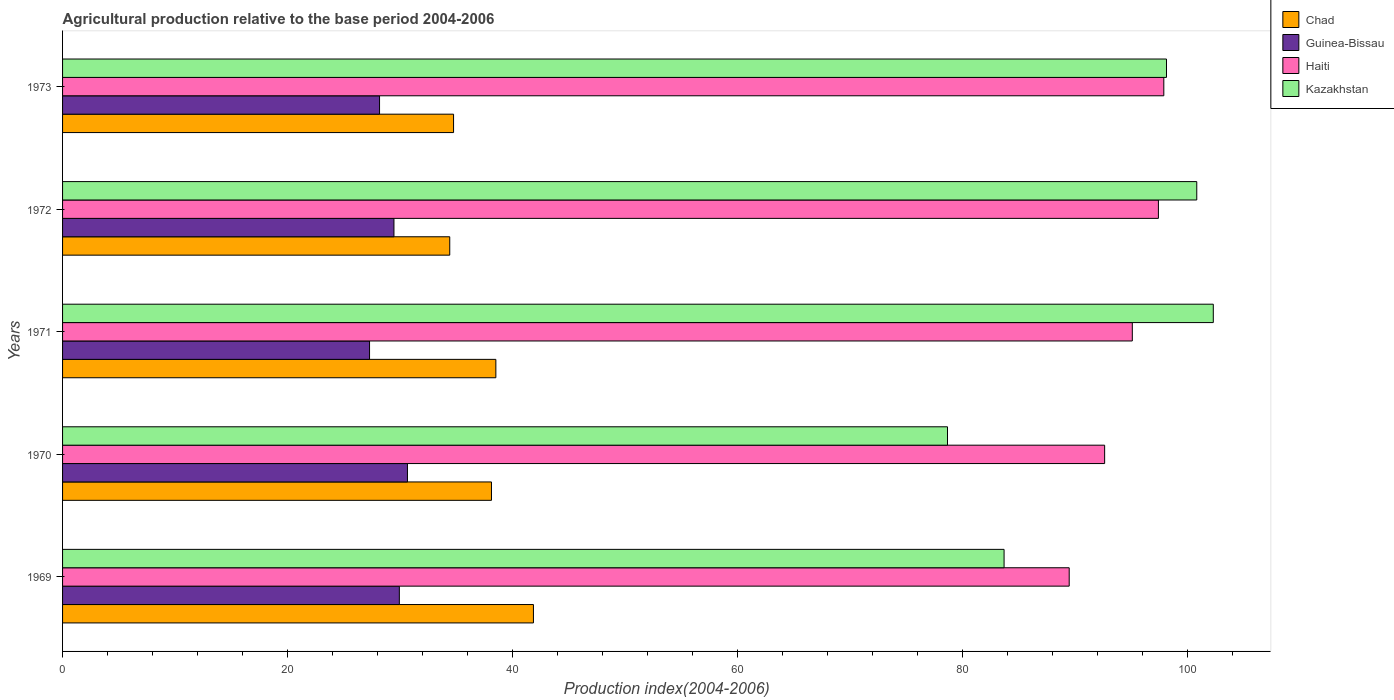How many different coloured bars are there?
Your answer should be compact. 4. How many groups of bars are there?
Ensure brevity in your answer.  5. Are the number of bars per tick equal to the number of legend labels?
Make the answer very short. Yes. Are the number of bars on each tick of the Y-axis equal?
Offer a terse response. Yes. How many bars are there on the 4th tick from the top?
Offer a very short reply. 4. What is the label of the 2nd group of bars from the top?
Offer a terse response. 1972. What is the agricultural production index in Chad in 1969?
Provide a short and direct response. 41.86. Across all years, what is the maximum agricultural production index in Haiti?
Your answer should be compact. 97.9. Across all years, what is the minimum agricultural production index in Guinea-Bissau?
Provide a succinct answer. 27.29. In which year was the agricultural production index in Chad maximum?
Give a very brief answer. 1969. In which year was the agricultural production index in Guinea-Bissau minimum?
Ensure brevity in your answer.  1971. What is the total agricultural production index in Chad in the graph?
Give a very brief answer. 187.69. What is the difference between the agricultural production index in Guinea-Bissau in 1969 and that in 1972?
Your answer should be compact. 0.48. What is the difference between the agricultural production index in Chad in 1973 and the agricultural production index in Guinea-Bissau in 1972?
Offer a very short reply. 5.3. What is the average agricultural production index in Kazakhstan per year?
Your answer should be compact. 92.73. In the year 1973, what is the difference between the agricultural production index in Kazakhstan and agricultural production index in Chad?
Your answer should be very brief. 63.38. In how many years, is the agricultural production index in Haiti greater than 96 ?
Keep it short and to the point. 2. What is the ratio of the agricultural production index in Chad in 1969 to that in 1973?
Ensure brevity in your answer.  1.2. Is the agricultural production index in Guinea-Bissau in 1969 less than that in 1970?
Make the answer very short. Yes. What is the difference between the highest and the second highest agricultural production index in Chad?
Your answer should be compact. 3.34. What is the difference between the highest and the lowest agricultural production index in Guinea-Bissau?
Keep it short and to the point. 3.37. Is it the case that in every year, the sum of the agricultural production index in Chad and agricultural production index in Kazakhstan is greater than the sum of agricultural production index in Haiti and agricultural production index in Guinea-Bissau?
Provide a succinct answer. Yes. What does the 2nd bar from the top in 1971 represents?
Give a very brief answer. Haiti. What does the 3rd bar from the bottom in 1969 represents?
Offer a very short reply. Haiti. Is it the case that in every year, the sum of the agricultural production index in Haiti and agricultural production index in Guinea-Bissau is greater than the agricultural production index in Chad?
Your response must be concise. Yes. Are all the bars in the graph horizontal?
Provide a succinct answer. Yes. How many legend labels are there?
Give a very brief answer. 4. What is the title of the graph?
Offer a very short reply. Agricultural production relative to the base period 2004-2006. Does "Turkey" appear as one of the legend labels in the graph?
Make the answer very short. No. What is the label or title of the X-axis?
Your response must be concise. Production index(2004-2006). What is the Production index(2004-2006) of Chad in 1969?
Your answer should be compact. 41.86. What is the Production index(2004-2006) in Guinea-Bissau in 1969?
Keep it short and to the point. 29.94. What is the Production index(2004-2006) of Haiti in 1969?
Make the answer very short. 89.49. What is the Production index(2004-2006) of Kazakhstan in 1969?
Your response must be concise. 83.7. What is the Production index(2004-2006) in Chad in 1970?
Your response must be concise. 38.13. What is the Production index(2004-2006) of Guinea-Bissau in 1970?
Give a very brief answer. 30.66. What is the Production index(2004-2006) of Haiti in 1970?
Your response must be concise. 92.64. What is the Production index(2004-2006) in Kazakhstan in 1970?
Provide a succinct answer. 78.67. What is the Production index(2004-2006) in Chad in 1971?
Your answer should be compact. 38.52. What is the Production index(2004-2006) in Guinea-Bissau in 1971?
Your answer should be very brief. 27.29. What is the Production index(2004-2006) of Haiti in 1971?
Provide a succinct answer. 95.1. What is the Production index(2004-2006) of Kazakhstan in 1971?
Your response must be concise. 102.3. What is the Production index(2004-2006) of Chad in 1972?
Provide a succinct answer. 34.42. What is the Production index(2004-2006) of Guinea-Bissau in 1972?
Make the answer very short. 29.46. What is the Production index(2004-2006) in Haiti in 1972?
Your answer should be very brief. 97.42. What is the Production index(2004-2006) in Kazakhstan in 1972?
Provide a succinct answer. 100.83. What is the Production index(2004-2006) in Chad in 1973?
Keep it short and to the point. 34.76. What is the Production index(2004-2006) of Guinea-Bissau in 1973?
Provide a short and direct response. 28.18. What is the Production index(2004-2006) of Haiti in 1973?
Give a very brief answer. 97.9. What is the Production index(2004-2006) of Kazakhstan in 1973?
Offer a terse response. 98.14. Across all years, what is the maximum Production index(2004-2006) of Chad?
Provide a short and direct response. 41.86. Across all years, what is the maximum Production index(2004-2006) of Guinea-Bissau?
Give a very brief answer. 30.66. Across all years, what is the maximum Production index(2004-2006) of Haiti?
Make the answer very short. 97.9. Across all years, what is the maximum Production index(2004-2006) in Kazakhstan?
Your answer should be compact. 102.3. Across all years, what is the minimum Production index(2004-2006) in Chad?
Your answer should be very brief. 34.42. Across all years, what is the minimum Production index(2004-2006) of Guinea-Bissau?
Ensure brevity in your answer.  27.29. Across all years, what is the minimum Production index(2004-2006) of Haiti?
Ensure brevity in your answer.  89.49. Across all years, what is the minimum Production index(2004-2006) of Kazakhstan?
Give a very brief answer. 78.67. What is the total Production index(2004-2006) of Chad in the graph?
Give a very brief answer. 187.69. What is the total Production index(2004-2006) of Guinea-Bissau in the graph?
Ensure brevity in your answer.  145.53. What is the total Production index(2004-2006) of Haiti in the graph?
Make the answer very short. 472.55. What is the total Production index(2004-2006) of Kazakhstan in the graph?
Ensure brevity in your answer.  463.64. What is the difference between the Production index(2004-2006) of Chad in 1969 and that in 1970?
Your response must be concise. 3.73. What is the difference between the Production index(2004-2006) of Guinea-Bissau in 1969 and that in 1970?
Keep it short and to the point. -0.72. What is the difference between the Production index(2004-2006) of Haiti in 1969 and that in 1970?
Your response must be concise. -3.15. What is the difference between the Production index(2004-2006) of Kazakhstan in 1969 and that in 1970?
Keep it short and to the point. 5.03. What is the difference between the Production index(2004-2006) in Chad in 1969 and that in 1971?
Ensure brevity in your answer.  3.34. What is the difference between the Production index(2004-2006) in Guinea-Bissau in 1969 and that in 1971?
Make the answer very short. 2.65. What is the difference between the Production index(2004-2006) in Haiti in 1969 and that in 1971?
Give a very brief answer. -5.61. What is the difference between the Production index(2004-2006) in Kazakhstan in 1969 and that in 1971?
Offer a terse response. -18.6. What is the difference between the Production index(2004-2006) of Chad in 1969 and that in 1972?
Your answer should be compact. 7.44. What is the difference between the Production index(2004-2006) of Guinea-Bissau in 1969 and that in 1972?
Provide a succinct answer. 0.48. What is the difference between the Production index(2004-2006) in Haiti in 1969 and that in 1972?
Offer a terse response. -7.93. What is the difference between the Production index(2004-2006) in Kazakhstan in 1969 and that in 1972?
Make the answer very short. -17.13. What is the difference between the Production index(2004-2006) of Guinea-Bissau in 1969 and that in 1973?
Keep it short and to the point. 1.76. What is the difference between the Production index(2004-2006) of Haiti in 1969 and that in 1973?
Provide a succinct answer. -8.41. What is the difference between the Production index(2004-2006) in Kazakhstan in 1969 and that in 1973?
Give a very brief answer. -14.44. What is the difference between the Production index(2004-2006) of Chad in 1970 and that in 1971?
Give a very brief answer. -0.39. What is the difference between the Production index(2004-2006) in Guinea-Bissau in 1970 and that in 1971?
Keep it short and to the point. 3.37. What is the difference between the Production index(2004-2006) in Haiti in 1970 and that in 1971?
Provide a short and direct response. -2.46. What is the difference between the Production index(2004-2006) in Kazakhstan in 1970 and that in 1971?
Provide a succinct answer. -23.63. What is the difference between the Production index(2004-2006) of Chad in 1970 and that in 1972?
Provide a short and direct response. 3.71. What is the difference between the Production index(2004-2006) in Haiti in 1970 and that in 1972?
Provide a short and direct response. -4.78. What is the difference between the Production index(2004-2006) of Kazakhstan in 1970 and that in 1972?
Ensure brevity in your answer.  -22.16. What is the difference between the Production index(2004-2006) in Chad in 1970 and that in 1973?
Keep it short and to the point. 3.37. What is the difference between the Production index(2004-2006) of Guinea-Bissau in 1970 and that in 1973?
Provide a succinct answer. 2.48. What is the difference between the Production index(2004-2006) in Haiti in 1970 and that in 1973?
Offer a terse response. -5.26. What is the difference between the Production index(2004-2006) of Kazakhstan in 1970 and that in 1973?
Offer a terse response. -19.47. What is the difference between the Production index(2004-2006) of Chad in 1971 and that in 1972?
Your answer should be very brief. 4.1. What is the difference between the Production index(2004-2006) of Guinea-Bissau in 1971 and that in 1972?
Your response must be concise. -2.17. What is the difference between the Production index(2004-2006) of Haiti in 1971 and that in 1972?
Your answer should be compact. -2.32. What is the difference between the Production index(2004-2006) in Kazakhstan in 1971 and that in 1972?
Give a very brief answer. 1.47. What is the difference between the Production index(2004-2006) in Chad in 1971 and that in 1973?
Provide a succinct answer. 3.76. What is the difference between the Production index(2004-2006) in Guinea-Bissau in 1971 and that in 1973?
Keep it short and to the point. -0.89. What is the difference between the Production index(2004-2006) of Kazakhstan in 1971 and that in 1973?
Provide a short and direct response. 4.16. What is the difference between the Production index(2004-2006) in Chad in 1972 and that in 1973?
Provide a short and direct response. -0.34. What is the difference between the Production index(2004-2006) of Guinea-Bissau in 1972 and that in 1973?
Offer a terse response. 1.28. What is the difference between the Production index(2004-2006) of Haiti in 1972 and that in 1973?
Ensure brevity in your answer.  -0.48. What is the difference between the Production index(2004-2006) of Kazakhstan in 1972 and that in 1973?
Provide a short and direct response. 2.69. What is the difference between the Production index(2004-2006) in Chad in 1969 and the Production index(2004-2006) in Guinea-Bissau in 1970?
Give a very brief answer. 11.2. What is the difference between the Production index(2004-2006) in Chad in 1969 and the Production index(2004-2006) in Haiti in 1970?
Keep it short and to the point. -50.78. What is the difference between the Production index(2004-2006) of Chad in 1969 and the Production index(2004-2006) of Kazakhstan in 1970?
Make the answer very short. -36.81. What is the difference between the Production index(2004-2006) in Guinea-Bissau in 1969 and the Production index(2004-2006) in Haiti in 1970?
Provide a short and direct response. -62.7. What is the difference between the Production index(2004-2006) in Guinea-Bissau in 1969 and the Production index(2004-2006) in Kazakhstan in 1970?
Offer a terse response. -48.73. What is the difference between the Production index(2004-2006) of Haiti in 1969 and the Production index(2004-2006) of Kazakhstan in 1970?
Offer a terse response. 10.82. What is the difference between the Production index(2004-2006) of Chad in 1969 and the Production index(2004-2006) of Guinea-Bissau in 1971?
Keep it short and to the point. 14.57. What is the difference between the Production index(2004-2006) of Chad in 1969 and the Production index(2004-2006) of Haiti in 1971?
Provide a short and direct response. -53.24. What is the difference between the Production index(2004-2006) in Chad in 1969 and the Production index(2004-2006) in Kazakhstan in 1971?
Offer a terse response. -60.44. What is the difference between the Production index(2004-2006) of Guinea-Bissau in 1969 and the Production index(2004-2006) of Haiti in 1971?
Keep it short and to the point. -65.16. What is the difference between the Production index(2004-2006) in Guinea-Bissau in 1969 and the Production index(2004-2006) in Kazakhstan in 1971?
Offer a very short reply. -72.36. What is the difference between the Production index(2004-2006) in Haiti in 1969 and the Production index(2004-2006) in Kazakhstan in 1971?
Provide a succinct answer. -12.81. What is the difference between the Production index(2004-2006) in Chad in 1969 and the Production index(2004-2006) in Guinea-Bissau in 1972?
Your answer should be compact. 12.4. What is the difference between the Production index(2004-2006) of Chad in 1969 and the Production index(2004-2006) of Haiti in 1972?
Offer a very short reply. -55.56. What is the difference between the Production index(2004-2006) in Chad in 1969 and the Production index(2004-2006) in Kazakhstan in 1972?
Your answer should be very brief. -58.97. What is the difference between the Production index(2004-2006) in Guinea-Bissau in 1969 and the Production index(2004-2006) in Haiti in 1972?
Your answer should be compact. -67.48. What is the difference between the Production index(2004-2006) of Guinea-Bissau in 1969 and the Production index(2004-2006) of Kazakhstan in 1972?
Provide a short and direct response. -70.89. What is the difference between the Production index(2004-2006) in Haiti in 1969 and the Production index(2004-2006) in Kazakhstan in 1972?
Your answer should be compact. -11.34. What is the difference between the Production index(2004-2006) of Chad in 1969 and the Production index(2004-2006) of Guinea-Bissau in 1973?
Offer a terse response. 13.68. What is the difference between the Production index(2004-2006) in Chad in 1969 and the Production index(2004-2006) in Haiti in 1973?
Your response must be concise. -56.04. What is the difference between the Production index(2004-2006) in Chad in 1969 and the Production index(2004-2006) in Kazakhstan in 1973?
Your response must be concise. -56.28. What is the difference between the Production index(2004-2006) of Guinea-Bissau in 1969 and the Production index(2004-2006) of Haiti in 1973?
Make the answer very short. -67.96. What is the difference between the Production index(2004-2006) in Guinea-Bissau in 1969 and the Production index(2004-2006) in Kazakhstan in 1973?
Offer a very short reply. -68.2. What is the difference between the Production index(2004-2006) of Haiti in 1969 and the Production index(2004-2006) of Kazakhstan in 1973?
Your answer should be very brief. -8.65. What is the difference between the Production index(2004-2006) in Chad in 1970 and the Production index(2004-2006) in Guinea-Bissau in 1971?
Your answer should be very brief. 10.84. What is the difference between the Production index(2004-2006) in Chad in 1970 and the Production index(2004-2006) in Haiti in 1971?
Give a very brief answer. -56.97. What is the difference between the Production index(2004-2006) of Chad in 1970 and the Production index(2004-2006) of Kazakhstan in 1971?
Your answer should be very brief. -64.17. What is the difference between the Production index(2004-2006) in Guinea-Bissau in 1970 and the Production index(2004-2006) in Haiti in 1971?
Offer a terse response. -64.44. What is the difference between the Production index(2004-2006) in Guinea-Bissau in 1970 and the Production index(2004-2006) in Kazakhstan in 1971?
Provide a short and direct response. -71.64. What is the difference between the Production index(2004-2006) of Haiti in 1970 and the Production index(2004-2006) of Kazakhstan in 1971?
Provide a short and direct response. -9.66. What is the difference between the Production index(2004-2006) in Chad in 1970 and the Production index(2004-2006) in Guinea-Bissau in 1972?
Your response must be concise. 8.67. What is the difference between the Production index(2004-2006) in Chad in 1970 and the Production index(2004-2006) in Haiti in 1972?
Provide a short and direct response. -59.29. What is the difference between the Production index(2004-2006) of Chad in 1970 and the Production index(2004-2006) of Kazakhstan in 1972?
Keep it short and to the point. -62.7. What is the difference between the Production index(2004-2006) in Guinea-Bissau in 1970 and the Production index(2004-2006) in Haiti in 1972?
Ensure brevity in your answer.  -66.76. What is the difference between the Production index(2004-2006) in Guinea-Bissau in 1970 and the Production index(2004-2006) in Kazakhstan in 1972?
Make the answer very short. -70.17. What is the difference between the Production index(2004-2006) of Haiti in 1970 and the Production index(2004-2006) of Kazakhstan in 1972?
Offer a very short reply. -8.19. What is the difference between the Production index(2004-2006) in Chad in 1970 and the Production index(2004-2006) in Guinea-Bissau in 1973?
Offer a terse response. 9.95. What is the difference between the Production index(2004-2006) of Chad in 1970 and the Production index(2004-2006) of Haiti in 1973?
Offer a very short reply. -59.77. What is the difference between the Production index(2004-2006) in Chad in 1970 and the Production index(2004-2006) in Kazakhstan in 1973?
Your answer should be very brief. -60.01. What is the difference between the Production index(2004-2006) in Guinea-Bissau in 1970 and the Production index(2004-2006) in Haiti in 1973?
Ensure brevity in your answer.  -67.24. What is the difference between the Production index(2004-2006) of Guinea-Bissau in 1970 and the Production index(2004-2006) of Kazakhstan in 1973?
Your answer should be very brief. -67.48. What is the difference between the Production index(2004-2006) of Haiti in 1970 and the Production index(2004-2006) of Kazakhstan in 1973?
Your response must be concise. -5.5. What is the difference between the Production index(2004-2006) of Chad in 1971 and the Production index(2004-2006) of Guinea-Bissau in 1972?
Offer a terse response. 9.06. What is the difference between the Production index(2004-2006) in Chad in 1971 and the Production index(2004-2006) in Haiti in 1972?
Make the answer very short. -58.9. What is the difference between the Production index(2004-2006) of Chad in 1971 and the Production index(2004-2006) of Kazakhstan in 1972?
Provide a succinct answer. -62.31. What is the difference between the Production index(2004-2006) in Guinea-Bissau in 1971 and the Production index(2004-2006) in Haiti in 1972?
Your answer should be very brief. -70.13. What is the difference between the Production index(2004-2006) of Guinea-Bissau in 1971 and the Production index(2004-2006) of Kazakhstan in 1972?
Ensure brevity in your answer.  -73.54. What is the difference between the Production index(2004-2006) in Haiti in 1971 and the Production index(2004-2006) in Kazakhstan in 1972?
Provide a succinct answer. -5.73. What is the difference between the Production index(2004-2006) in Chad in 1971 and the Production index(2004-2006) in Guinea-Bissau in 1973?
Your answer should be very brief. 10.34. What is the difference between the Production index(2004-2006) in Chad in 1971 and the Production index(2004-2006) in Haiti in 1973?
Make the answer very short. -59.38. What is the difference between the Production index(2004-2006) in Chad in 1971 and the Production index(2004-2006) in Kazakhstan in 1973?
Make the answer very short. -59.62. What is the difference between the Production index(2004-2006) of Guinea-Bissau in 1971 and the Production index(2004-2006) of Haiti in 1973?
Offer a terse response. -70.61. What is the difference between the Production index(2004-2006) in Guinea-Bissau in 1971 and the Production index(2004-2006) in Kazakhstan in 1973?
Offer a terse response. -70.85. What is the difference between the Production index(2004-2006) in Haiti in 1971 and the Production index(2004-2006) in Kazakhstan in 1973?
Make the answer very short. -3.04. What is the difference between the Production index(2004-2006) in Chad in 1972 and the Production index(2004-2006) in Guinea-Bissau in 1973?
Give a very brief answer. 6.24. What is the difference between the Production index(2004-2006) of Chad in 1972 and the Production index(2004-2006) of Haiti in 1973?
Your answer should be very brief. -63.48. What is the difference between the Production index(2004-2006) in Chad in 1972 and the Production index(2004-2006) in Kazakhstan in 1973?
Offer a terse response. -63.72. What is the difference between the Production index(2004-2006) of Guinea-Bissau in 1972 and the Production index(2004-2006) of Haiti in 1973?
Keep it short and to the point. -68.44. What is the difference between the Production index(2004-2006) in Guinea-Bissau in 1972 and the Production index(2004-2006) in Kazakhstan in 1973?
Ensure brevity in your answer.  -68.68. What is the difference between the Production index(2004-2006) of Haiti in 1972 and the Production index(2004-2006) of Kazakhstan in 1973?
Your response must be concise. -0.72. What is the average Production index(2004-2006) of Chad per year?
Your response must be concise. 37.54. What is the average Production index(2004-2006) in Guinea-Bissau per year?
Keep it short and to the point. 29.11. What is the average Production index(2004-2006) of Haiti per year?
Offer a very short reply. 94.51. What is the average Production index(2004-2006) in Kazakhstan per year?
Your response must be concise. 92.73. In the year 1969, what is the difference between the Production index(2004-2006) of Chad and Production index(2004-2006) of Guinea-Bissau?
Provide a short and direct response. 11.92. In the year 1969, what is the difference between the Production index(2004-2006) of Chad and Production index(2004-2006) of Haiti?
Your response must be concise. -47.63. In the year 1969, what is the difference between the Production index(2004-2006) in Chad and Production index(2004-2006) in Kazakhstan?
Provide a succinct answer. -41.84. In the year 1969, what is the difference between the Production index(2004-2006) of Guinea-Bissau and Production index(2004-2006) of Haiti?
Ensure brevity in your answer.  -59.55. In the year 1969, what is the difference between the Production index(2004-2006) of Guinea-Bissau and Production index(2004-2006) of Kazakhstan?
Make the answer very short. -53.76. In the year 1969, what is the difference between the Production index(2004-2006) of Haiti and Production index(2004-2006) of Kazakhstan?
Your response must be concise. 5.79. In the year 1970, what is the difference between the Production index(2004-2006) in Chad and Production index(2004-2006) in Guinea-Bissau?
Keep it short and to the point. 7.47. In the year 1970, what is the difference between the Production index(2004-2006) of Chad and Production index(2004-2006) of Haiti?
Make the answer very short. -54.51. In the year 1970, what is the difference between the Production index(2004-2006) in Chad and Production index(2004-2006) in Kazakhstan?
Make the answer very short. -40.54. In the year 1970, what is the difference between the Production index(2004-2006) in Guinea-Bissau and Production index(2004-2006) in Haiti?
Provide a short and direct response. -61.98. In the year 1970, what is the difference between the Production index(2004-2006) in Guinea-Bissau and Production index(2004-2006) in Kazakhstan?
Provide a short and direct response. -48.01. In the year 1970, what is the difference between the Production index(2004-2006) in Haiti and Production index(2004-2006) in Kazakhstan?
Provide a short and direct response. 13.97. In the year 1971, what is the difference between the Production index(2004-2006) of Chad and Production index(2004-2006) of Guinea-Bissau?
Give a very brief answer. 11.23. In the year 1971, what is the difference between the Production index(2004-2006) in Chad and Production index(2004-2006) in Haiti?
Provide a short and direct response. -56.58. In the year 1971, what is the difference between the Production index(2004-2006) in Chad and Production index(2004-2006) in Kazakhstan?
Ensure brevity in your answer.  -63.78. In the year 1971, what is the difference between the Production index(2004-2006) in Guinea-Bissau and Production index(2004-2006) in Haiti?
Provide a short and direct response. -67.81. In the year 1971, what is the difference between the Production index(2004-2006) in Guinea-Bissau and Production index(2004-2006) in Kazakhstan?
Make the answer very short. -75.01. In the year 1971, what is the difference between the Production index(2004-2006) in Haiti and Production index(2004-2006) in Kazakhstan?
Make the answer very short. -7.2. In the year 1972, what is the difference between the Production index(2004-2006) of Chad and Production index(2004-2006) of Guinea-Bissau?
Offer a terse response. 4.96. In the year 1972, what is the difference between the Production index(2004-2006) of Chad and Production index(2004-2006) of Haiti?
Provide a succinct answer. -63. In the year 1972, what is the difference between the Production index(2004-2006) in Chad and Production index(2004-2006) in Kazakhstan?
Your answer should be compact. -66.41. In the year 1972, what is the difference between the Production index(2004-2006) of Guinea-Bissau and Production index(2004-2006) of Haiti?
Your response must be concise. -67.96. In the year 1972, what is the difference between the Production index(2004-2006) of Guinea-Bissau and Production index(2004-2006) of Kazakhstan?
Make the answer very short. -71.37. In the year 1972, what is the difference between the Production index(2004-2006) in Haiti and Production index(2004-2006) in Kazakhstan?
Ensure brevity in your answer.  -3.41. In the year 1973, what is the difference between the Production index(2004-2006) of Chad and Production index(2004-2006) of Guinea-Bissau?
Your answer should be very brief. 6.58. In the year 1973, what is the difference between the Production index(2004-2006) of Chad and Production index(2004-2006) of Haiti?
Your answer should be very brief. -63.14. In the year 1973, what is the difference between the Production index(2004-2006) in Chad and Production index(2004-2006) in Kazakhstan?
Provide a succinct answer. -63.38. In the year 1973, what is the difference between the Production index(2004-2006) in Guinea-Bissau and Production index(2004-2006) in Haiti?
Provide a short and direct response. -69.72. In the year 1973, what is the difference between the Production index(2004-2006) of Guinea-Bissau and Production index(2004-2006) of Kazakhstan?
Your answer should be compact. -69.96. In the year 1973, what is the difference between the Production index(2004-2006) of Haiti and Production index(2004-2006) of Kazakhstan?
Provide a short and direct response. -0.24. What is the ratio of the Production index(2004-2006) of Chad in 1969 to that in 1970?
Your answer should be compact. 1.1. What is the ratio of the Production index(2004-2006) of Guinea-Bissau in 1969 to that in 1970?
Your response must be concise. 0.98. What is the ratio of the Production index(2004-2006) in Haiti in 1969 to that in 1970?
Ensure brevity in your answer.  0.97. What is the ratio of the Production index(2004-2006) in Kazakhstan in 1969 to that in 1970?
Provide a short and direct response. 1.06. What is the ratio of the Production index(2004-2006) in Chad in 1969 to that in 1971?
Keep it short and to the point. 1.09. What is the ratio of the Production index(2004-2006) in Guinea-Bissau in 1969 to that in 1971?
Your answer should be compact. 1.1. What is the ratio of the Production index(2004-2006) of Haiti in 1969 to that in 1971?
Offer a terse response. 0.94. What is the ratio of the Production index(2004-2006) of Kazakhstan in 1969 to that in 1971?
Make the answer very short. 0.82. What is the ratio of the Production index(2004-2006) in Chad in 1969 to that in 1972?
Keep it short and to the point. 1.22. What is the ratio of the Production index(2004-2006) of Guinea-Bissau in 1969 to that in 1972?
Make the answer very short. 1.02. What is the ratio of the Production index(2004-2006) of Haiti in 1969 to that in 1972?
Your response must be concise. 0.92. What is the ratio of the Production index(2004-2006) in Kazakhstan in 1969 to that in 1972?
Your answer should be very brief. 0.83. What is the ratio of the Production index(2004-2006) of Chad in 1969 to that in 1973?
Your answer should be compact. 1.2. What is the ratio of the Production index(2004-2006) in Guinea-Bissau in 1969 to that in 1973?
Make the answer very short. 1.06. What is the ratio of the Production index(2004-2006) of Haiti in 1969 to that in 1973?
Make the answer very short. 0.91. What is the ratio of the Production index(2004-2006) of Kazakhstan in 1969 to that in 1973?
Provide a succinct answer. 0.85. What is the ratio of the Production index(2004-2006) in Guinea-Bissau in 1970 to that in 1971?
Provide a short and direct response. 1.12. What is the ratio of the Production index(2004-2006) in Haiti in 1970 to that in 1971?
Your answer should be very brief. 0.97. What is the ratio of the Production index(2004-2006) in Kazakhstan in 1970 to that in 1971?
Your answer should be compact. 0.77. What is the ratio of the Production index(2004-2006) of Chad in 1970 to that in 1972?
Give a very brief answer. 1.11. What is the ratio of the Production index(2004-2006) of Guinea-Bissau in 1970 to that in 1972?
Your answer should be compact. 1.04. What is the ratio of the Production index(2004-2006) in Haiti in 1970 to that in 1972?
Your answer should be compact. 0.95. What is the ratio of the Production index(2004-2006) of Kazakhstan in 1970 to that in 1972?
Offer a very short reply. 0.78. What is the ratio of the Production index(2004-2006) of Chad in 1970 to that in 1973?
Provide a short and direct response. 1.1. What is the ratio of the Production index(2004-2006) of Guinea-Bissau in 1970 to that in 1973?
Offer a terse response. 1.09. What is the ratio of the Production index(2004-2006) in Haiti in 1970 to that in 1973?
Your response must be concise. 0.95. What is the ratio of the Production index(2004-2006) of Kazakhstan in 1970 to that in 1973?
Provide a succinct answer. 0.8. What is the ratio of the Production index(2004-2006) in Chad in 1971 to that in 1972?
Offer a terse response. 1.12. What is the ratio of the Production index(2004-2006) in Guinea-Bissau in 1971 to that in 1972?
Provide a succinct answer. 0.93. What is the ratio of the Production index(2004-2006) of Haiti in 1971 to that in 1972?
Offer a terse response. 0.98. What is the ratio of the Production index(2004-2006) in Kazakhstan in 1971 to that in 1972?
Keep it short and to the point. 1.01. What is the ratio of the Production index(2004-2006) of Chad in 1971 to that in 1973?
Give a very brief answer. 1.11. What is the ratio of the Production index(2004-2006) in Guinea-Bissau in 1971 to that in 1973?
Offer a terse response. 0.97. What is the ratio of the Production index(2004-2006) of Haiti in 1971 to that in 1973?
Your response must be concise. 0.97. What is the ratio of the Production index(2004-2006) in Kazakhstan in 1971 to that in 1973?
Your answer should be very brief. 1.04. What is the ratio of the Production index(2004-2006) in Chad in 1972 to that in 1973?
Offer a terse response. 0.99. What is the ratio of the Production index(2004-2006) of Guinea-Bissau in 1972 to that in 1973?
Your response must be concise. 1.05. What is the ratio of the Production index(2004-2006) of Haiti in 1972 to that in 1973?
Give a very brief answer. 1. What is the ratio of the Production index(2004-2006) in Kazakhstan in 1972 to that in 1973?
Make the answer very short. 1.03. What is the difference between the highest and the second highest Production index(2004-2006) of Chad?
Offer a terse response. 3.34. What is the difference between the highest and the second highest Production index(2004-2006) of Guinea-Bissau?
Offer a terse response. 0.72. What is the difference between the highest and the second highest Production index(2004-2006) in Haiti?
Provide a short and direct response. 0.48. What is the difference between the highest and the second highest Production index(2004-2006) in Kazakhstan?
Offer a very short reply. 1.47. What is the difference between the highest and the lowest Production index(2004-2006) of Chad?
Give a very brief answer. 7.44. What is the difference between the highest and the lowest Production index(2004-2006) of Guinea-Bissau?
Offer a very short reply. 3.37. What is the difference between the highest and the lowest Production index(2004-2006) in Haiti?
Provide a succinct answer. 8.41. What is the difference between the highest and the lowest Production index(2004-2006) in Kazakhstan?
Your response must be concise. 23.63. 